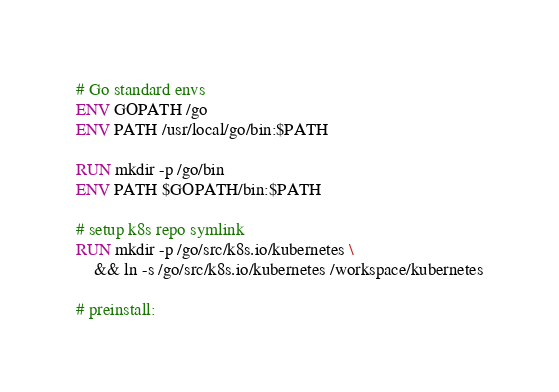<code> <loc_0><loc_0><loc_500><loc_500><_Dockerfile_>
# Go standard envs
ENV GOPATH /go
ENV PATH /usr/local/go/bin:$PATH

RUN mkdir -p /go/bin
ENV PATH $GOPATH/bin:$PATH

# setup k8s repo symlink
RUN mkdir -p /go/src/k8s.io/kubernetes \
    && ln -s /go/src/k8s.io/kubernetes /workspace/kubernetes

# preinstall:</code> 